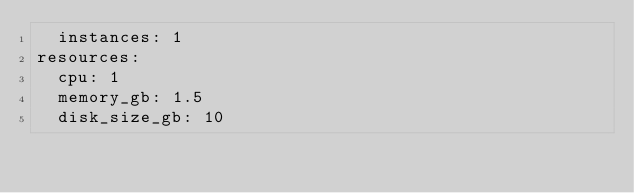<code> <loc_0><loc_0><loc_500><loc_500><_YAML_>  instances: 1
resources:
  cpu: 1
  memory_gb: 1.5
  disk_size_gb: 10
</code> 